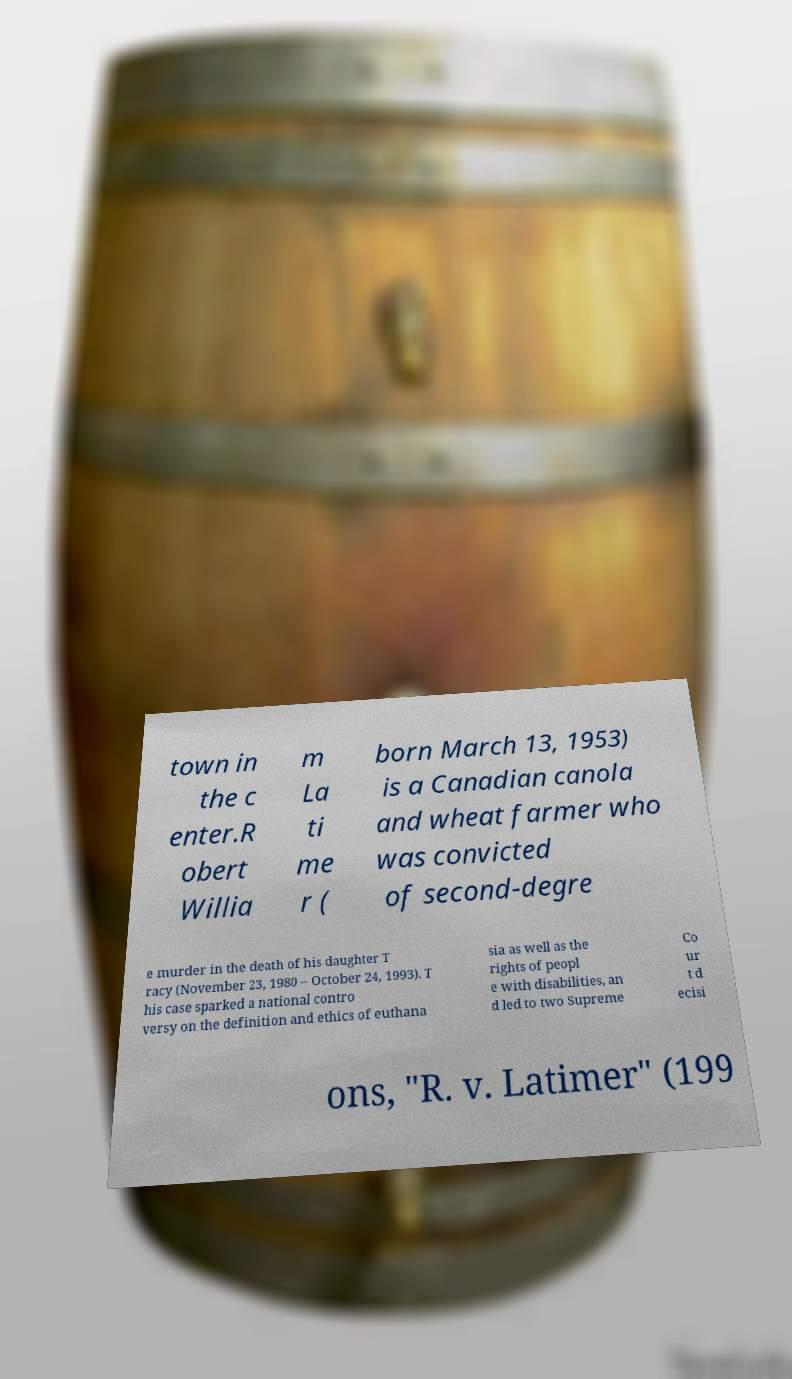Please read and relay the text visible in this image. What does it say? town in the c enter.R obert Willia m La ti me r ( born March 13, 1953) is a Canadian canola and wheat farmer who was convicted of second-degre e murder in the death of his daughter T racy (November 23, 1980 – October 24, 1993). T his case sparked a national contro versy on the definition and ethics of euthana sia as well as the rights of peopl e with disabilities, an d led to two Supreme Co ur t d ecisi ons, "R. v. Latimer" (199 